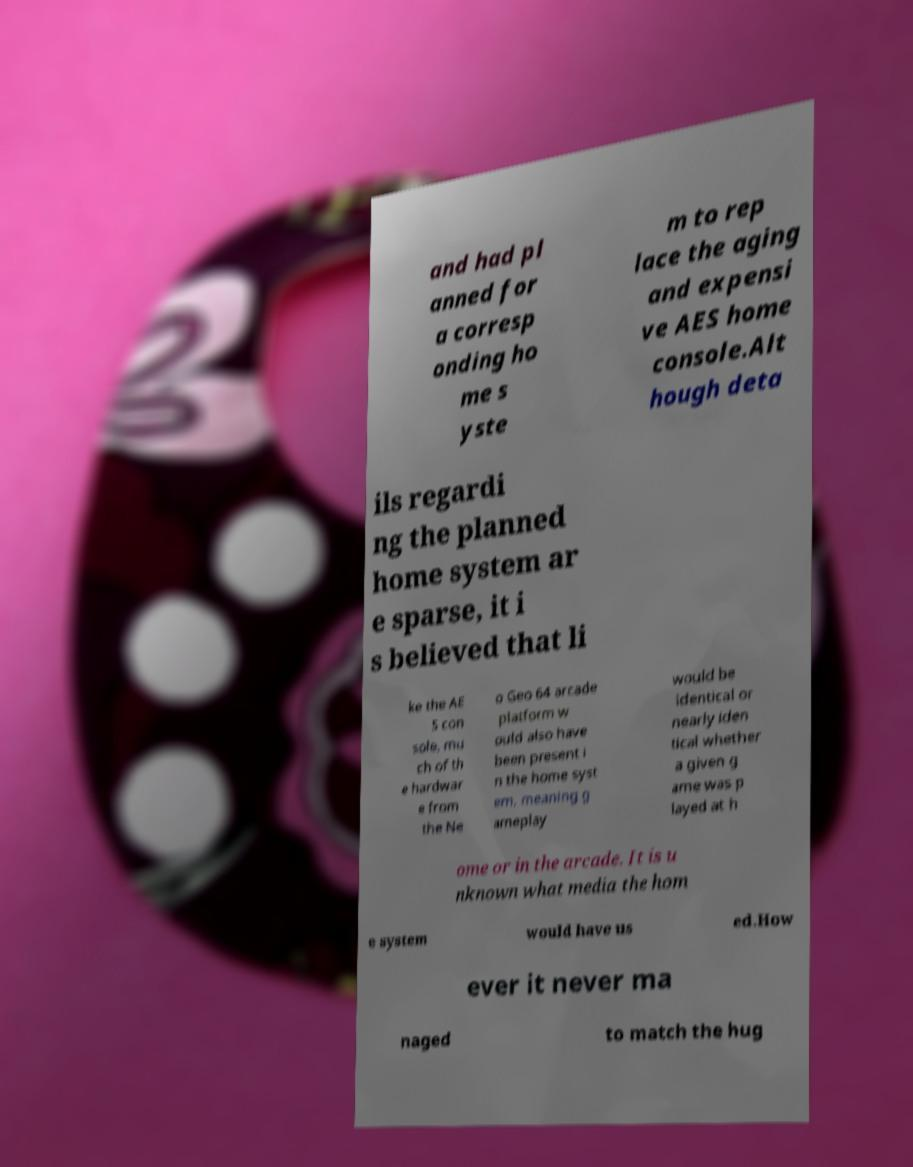Could you assist in decoding the text presented in this image and type it out clearly? and had pl anned for a corresp onding ho me s yste m to rep lace the aging and expensi ve AES home console.Alt hough deta ils regardi ng the planned home system ar e sparse, it i s believed that li ke the AE S con sole, mu ch of th e hardwar e from the Ne o Geo 64 arcade platform w ould also have been present i n the home syst em, meaning g ameplay would be identical or nearly iden tical whether a given g ame was p layed at h ome or in the arcade. It is u nknown what media the hom e system would have us ed.How ever it never ma naged to match the hug 